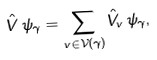<formula> <loc_0><loc_0><loc_500><loc_500>\hat { V } \, \psi _ { \gamma } = \sum _ { v \in \mathcal { V } ( \gamma ) } \hat { V } _ { v } \, \psi _ { \gamma } ,</formula> 